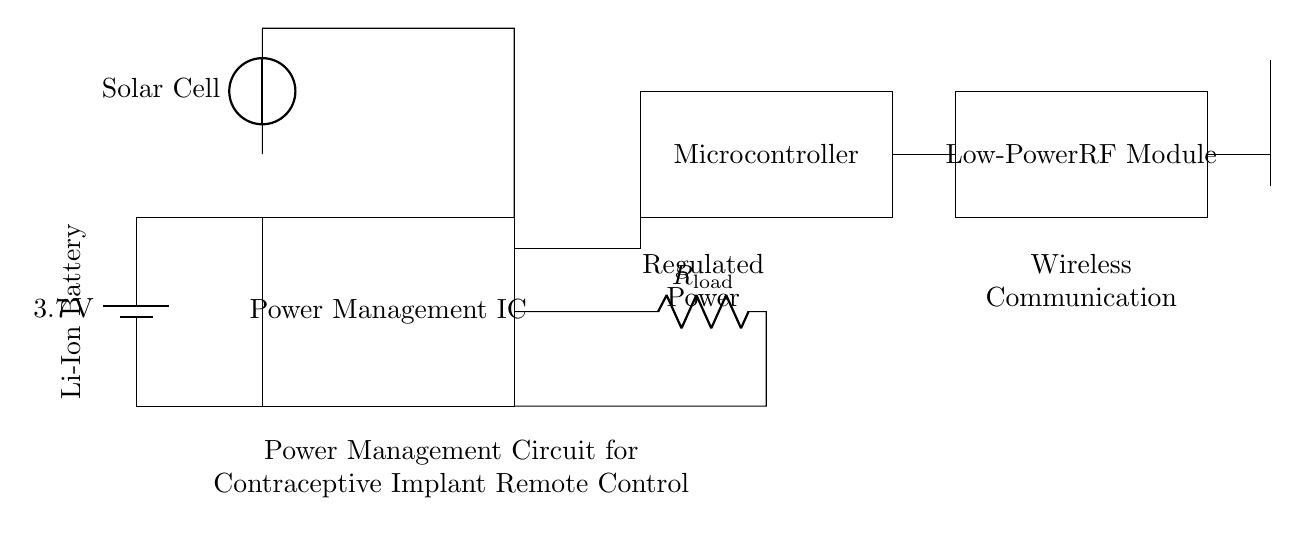What is the voltage of the battery? The circuit has a battery labeled as 3.7 volts, indicating the potential difference it supplies for the circuit.
Answer: 3.7 volts What component regulates the power to the microcontroller? The Power Management IC is the component responsible for managing and regulating the power supply to other components like the microcontroller.
Answer: Power Management IC How many components are connected to the battery? The battery connects to the Power Management IC and the load resistor, making it a total of two components connected directly to the battery's terminals.
Answer: Two What is the function of the low-power RF module? The low-power RF module is designed to facilitate wireless communication, typically for sending or receiving data remotely, which is essential for remote control functionality.
Answer: Wireless communication What type of energy source is used in the circuit? The circuit features a lithium-ion battery as the primary energy source, but it also includes an optional solar cell, indicating the use of both battery and solar energy sources in the overall design.
Answer: Lithium-ion and Solar Cell What does the antenna do in this circuit? The antenna is used for wireless transmission, allowing the circuit to send and receive signals over the air, crucial for the remote control function of the contraceptive implant.
Answer: Wireless transmission What type of resistor is included in the circuit? The circuit includes a load resistor, which limits the current to the load, ensuring that the components operate within their specified limits.
Answer: Load resistor 